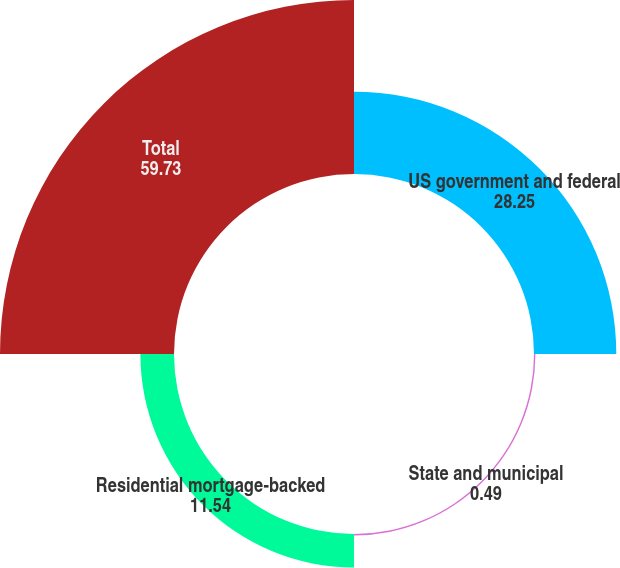Convert chart to OTSL. <chart><loc_0><loc_0><loc_500><loc_500><pie_chart><fcel>US government and federal<fcel>State and municipal<fcel>Residential mortgage-backed<fcel>Total<nl><fcel>28.25%<fcel>0.49%<fcel>11.54%<fcel>59.73%<nl></chart> 